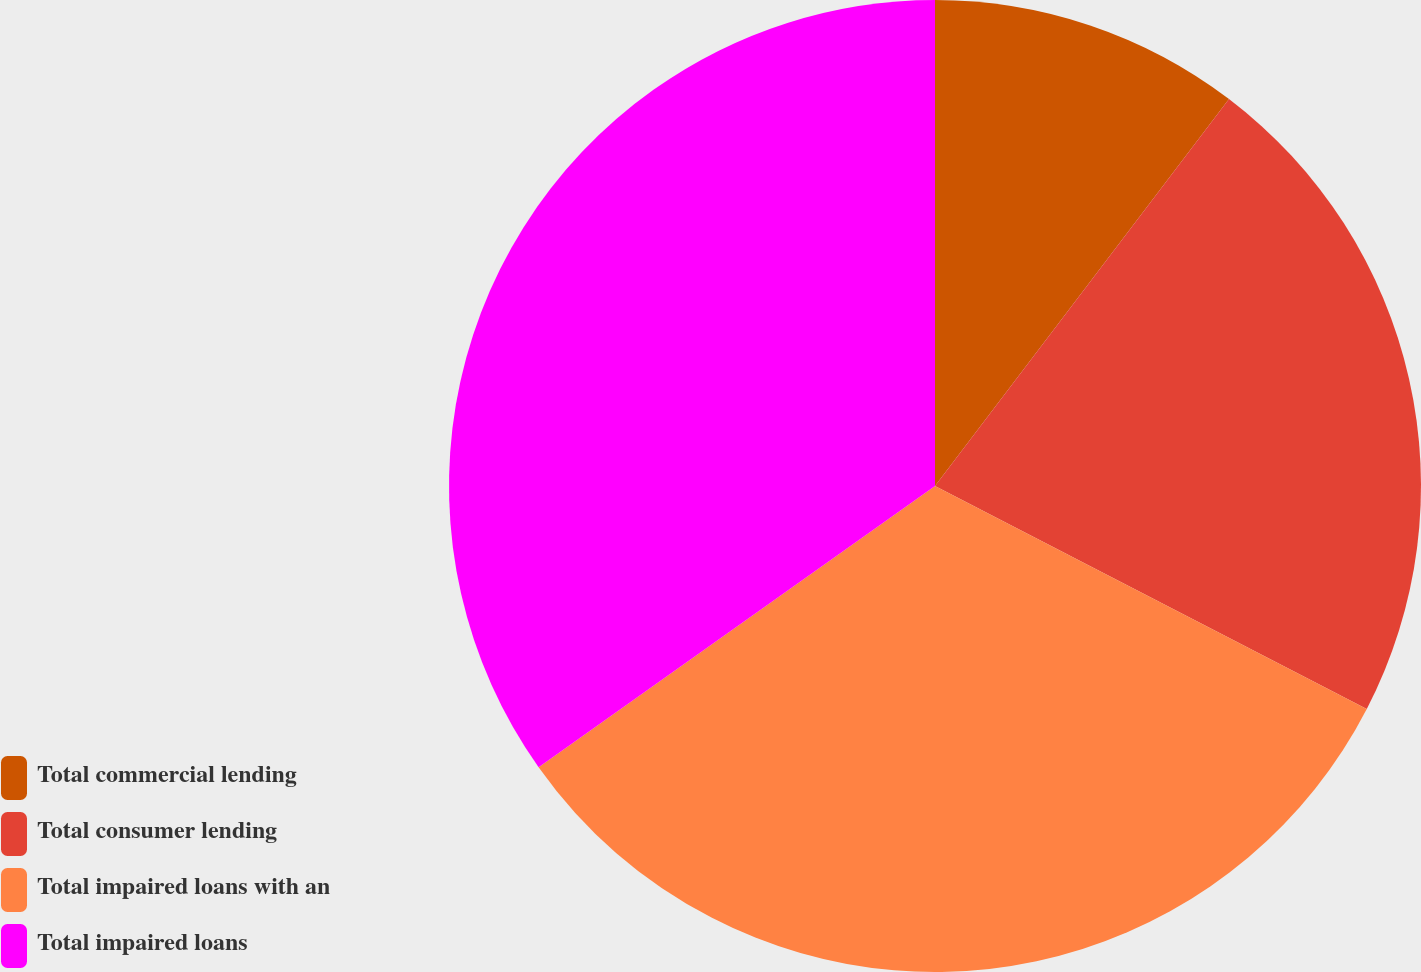Convert chart. <chart><loc_0><loc_0><loc_500><loc_500><pie_chart><fcel>Total commercial lending<fcel>Total consumer lending<fcel>Total impaired loans with an<fcel>Total impaired loans<nl><fcel>10.34%<fcel>22.25%<fcel>32.59%<fcel>34.82%<nl></chart> 